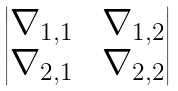<formula> <loc_0><loc_0><loc_500><loc_500>\begin{vmatrix} \nabla _ { 1 , 1 } \, & \, \nabla _ { 1 , 2 } \\ \nabla _ { 2 , 1 } \, & \, \nabla _ { 2 , 2 } \end{vmatrix}</formula> 